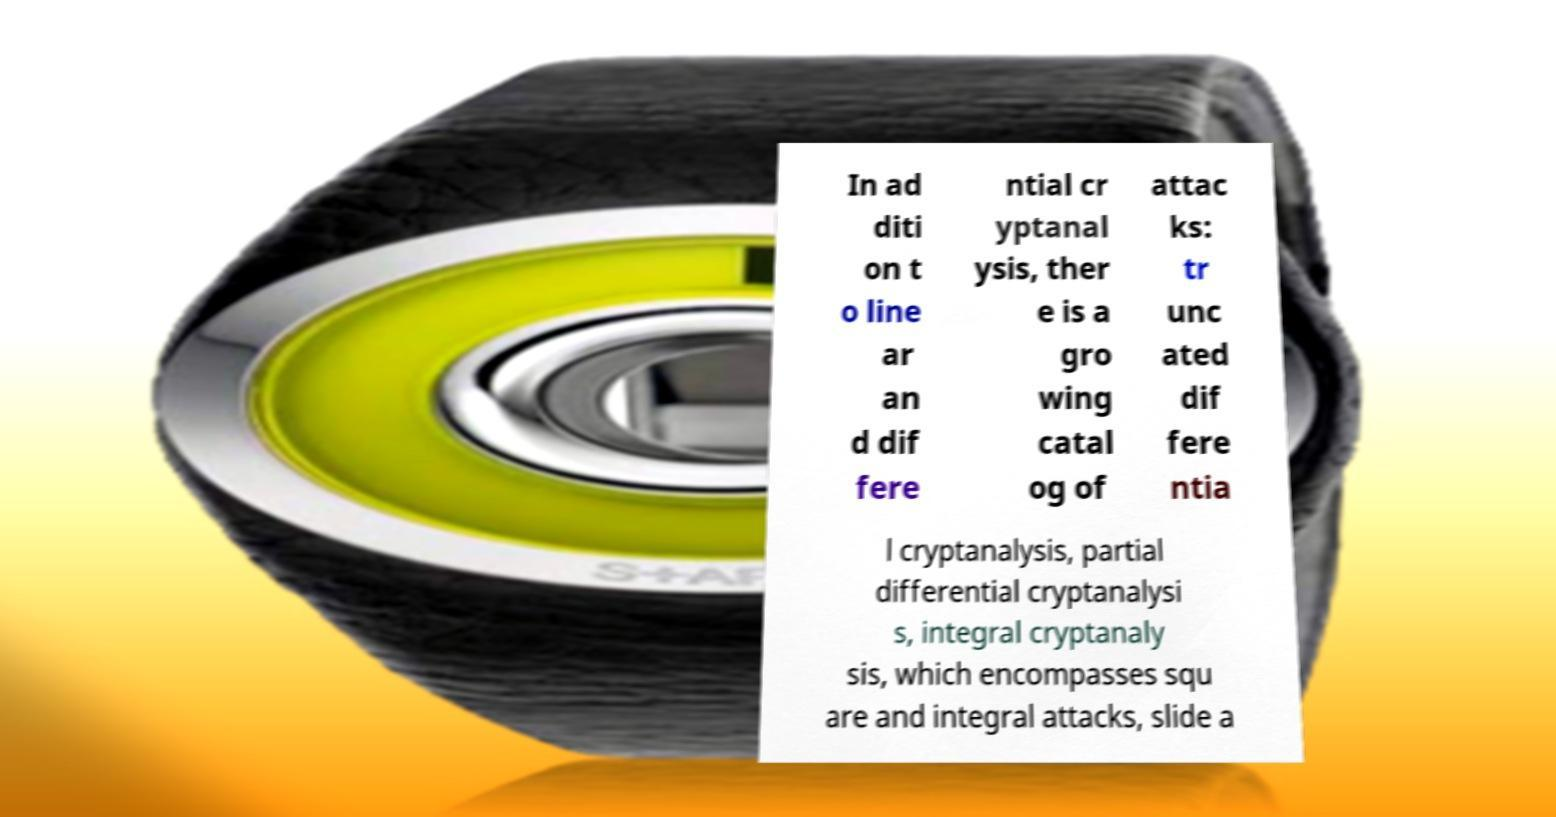Could you extract and type out the text from this image? In ad diti on t o line ar an d dif fere ntial cr yptanal ysis, ther e is a gro wing catal og of attac ks: tr unc ated dif fere ntia l cryptanalysis, partial differential cryptanalysi s, integral cryptanaly sis, which encompasses squ are and integral attacks, slide a 